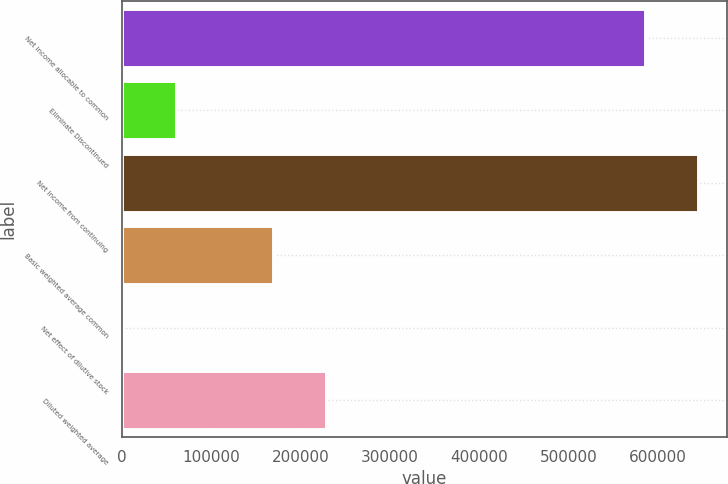Convert chart. <chart><loc_0><loc_0><loc_500><loc_500><bar_chart><fcel>Net income allocable to common<fcel>Eliminate Discontinued<fcel>Net income from continuing<fcel>Basic weighted average common<fcel>Net effect of dilutive stock<fcel>Diluted weighted average<nl><fcel>585966<fcel>59852.5<fcel>645408<fcel>168358<fcel>410<fcel>227800<nl></chart> 